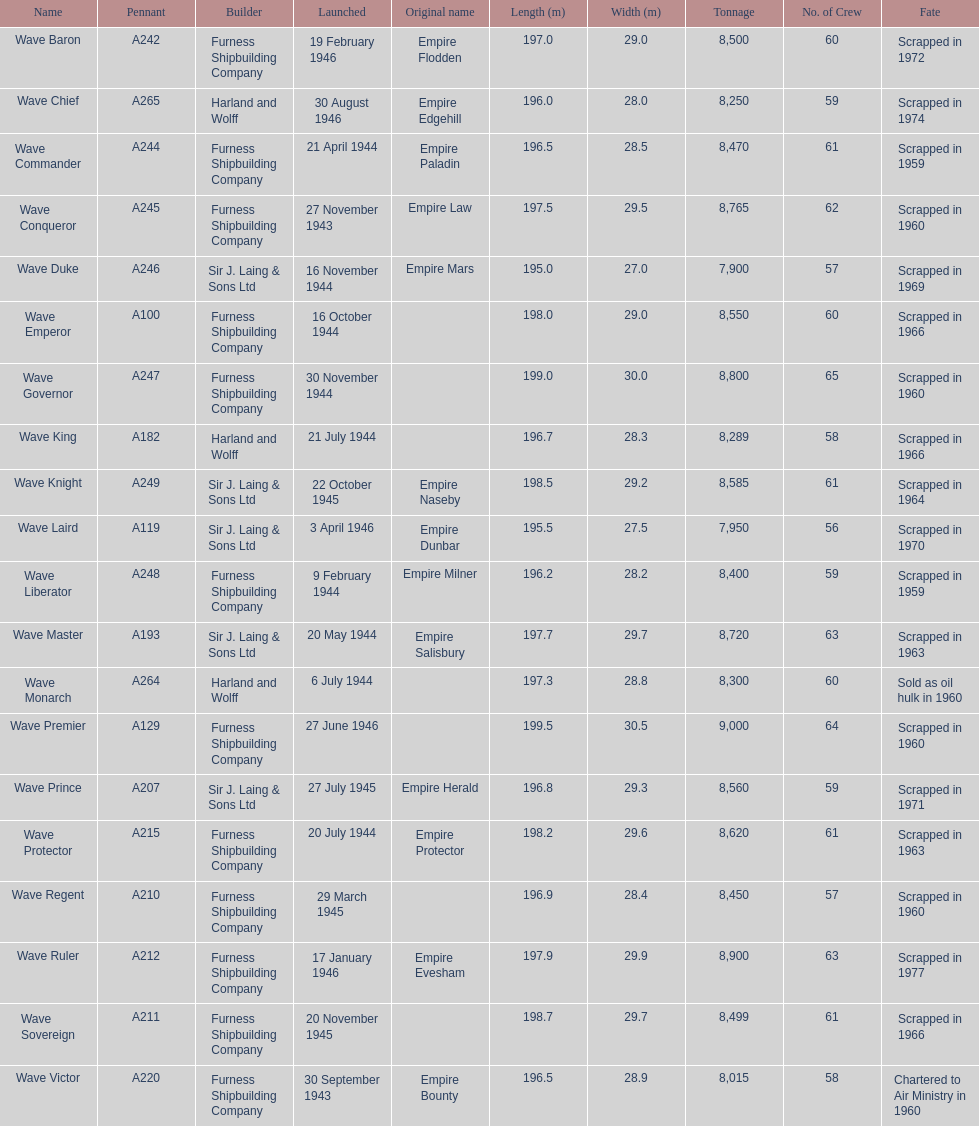What date was the first ship launched? 30 September 1943. 